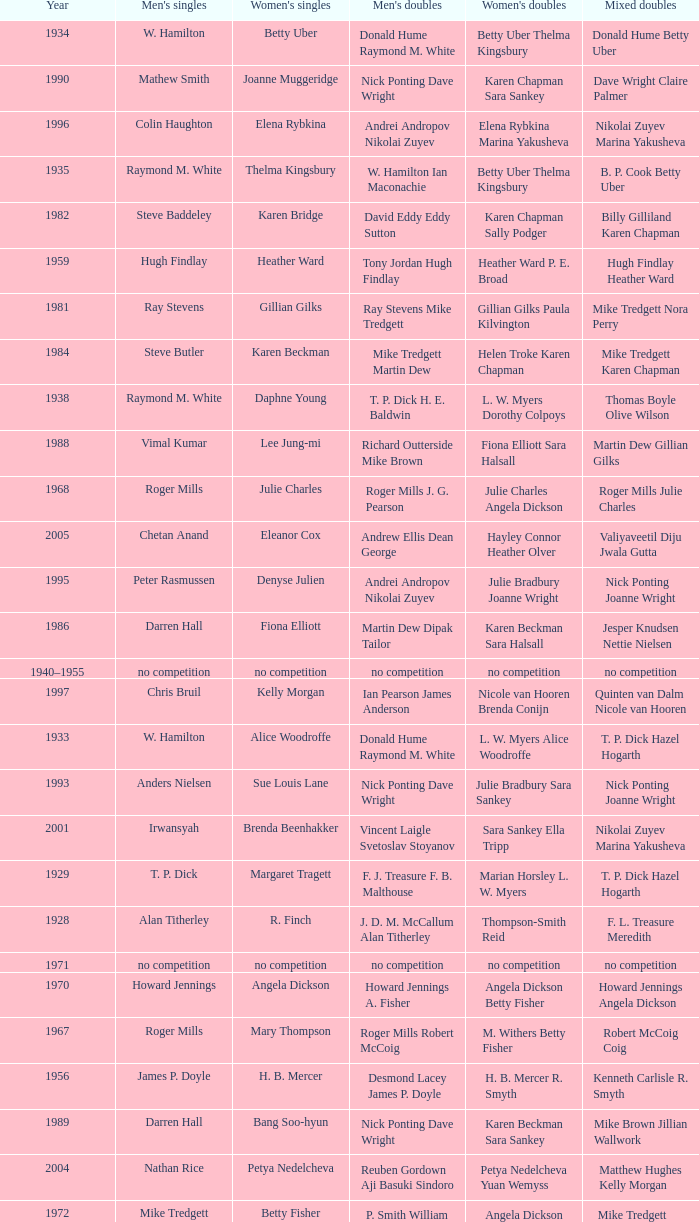Who won the Men's singles in the year that Ian Maconachie Marian Horsley won the Mixed doubles? Raymond M. White. 